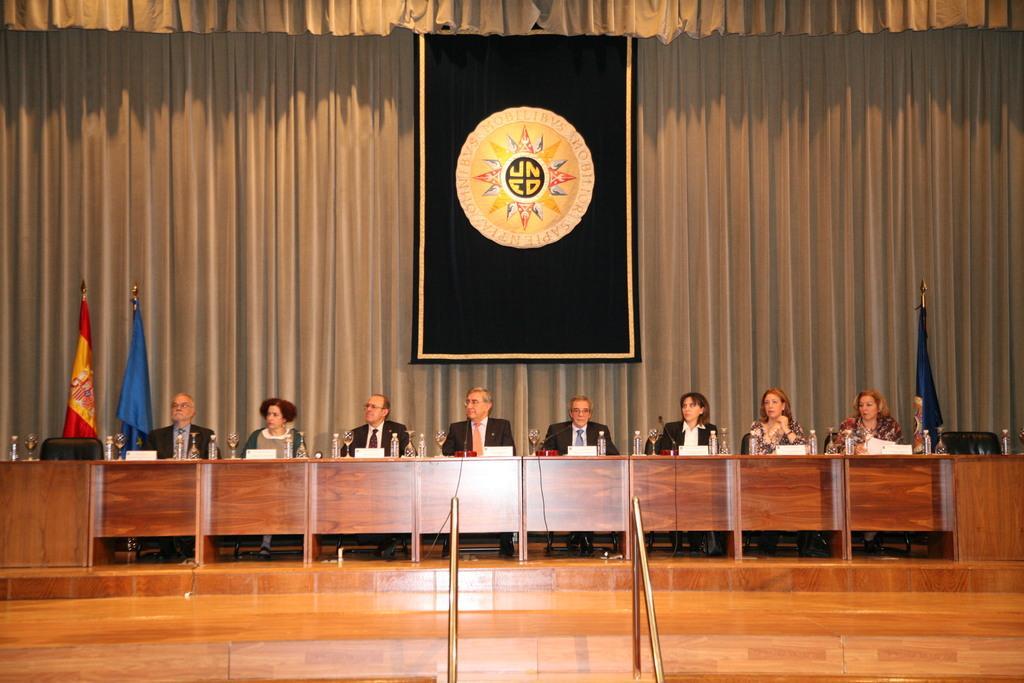Could you give a brief overview of what you see in this image? In this picture I can see there are few people sitting here there is a table in front of them and there are water bottles, wine glasses, name boards placed on the table. In the backdrop there is a curtain and there are flags. 